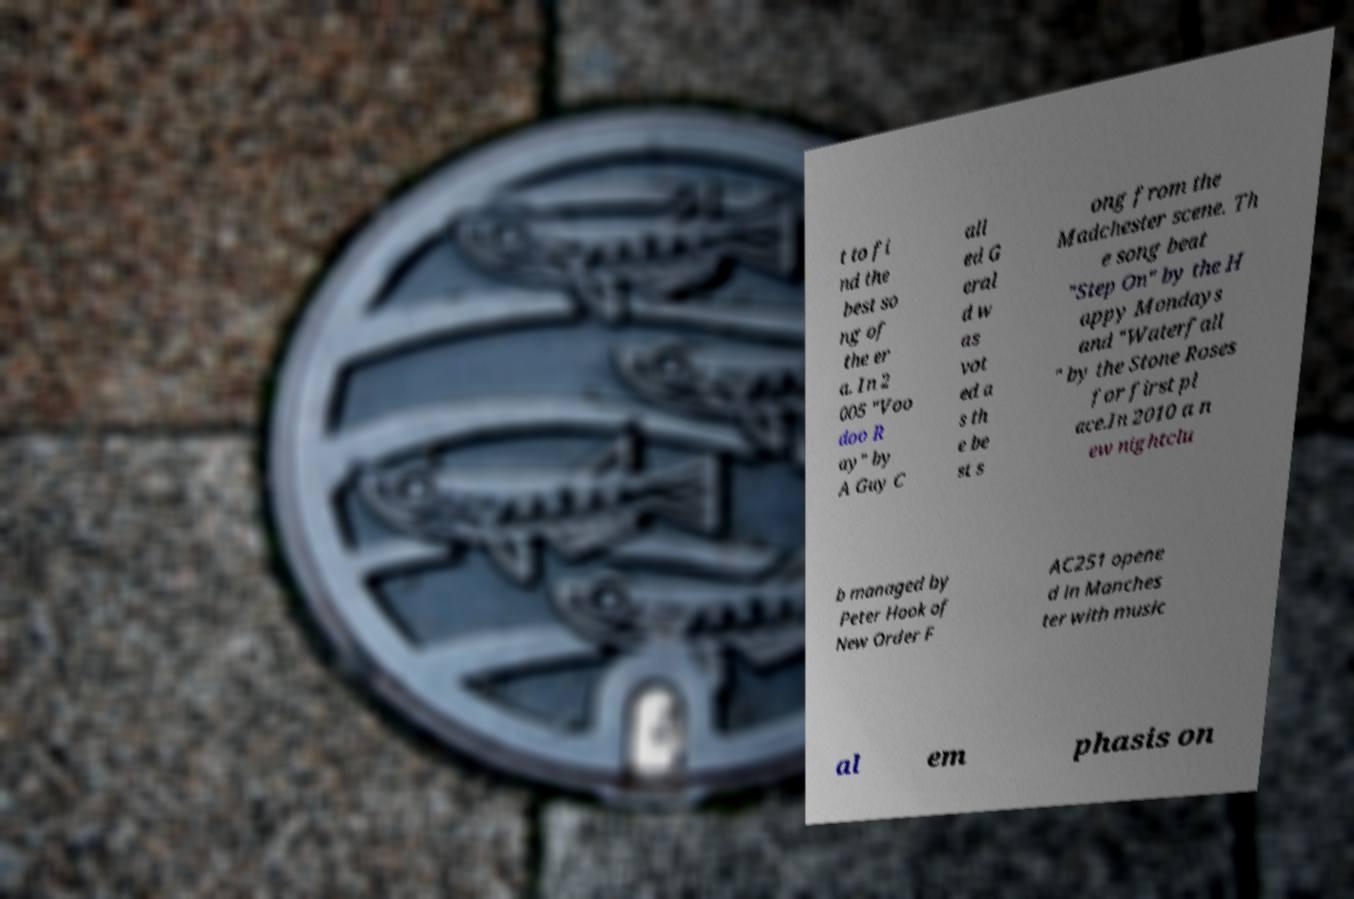Please identify and transcribe the text found in this image. t to fi nd the best so ng of the er a. In 2 005 "Voo doo R ay" by A Guy C all ed G eral d w as vot ed a s th e be st s ong from the Madchester scene. Th e song beat "Step On" by the H appy Mondays and "Waterfall " by the Stone Roses for first pl ace.In 2010 a n ew nightclu b managed by Peter Hook of New Order F AC251 opene d in Manches ter with music al em phasis on 